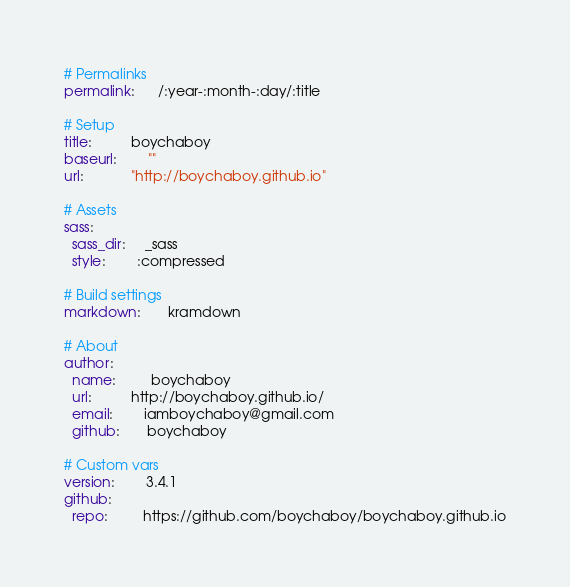Convert code to text. <code><loc_0><loc_0><loc_500><loc_500><_YAML_># Permalinks
permalink:      /:year-:month-:day/:title

# Setup
title:          boychaboy
baseurl:        ""
url:            "http://boychaboy.github.io"

# Assets
sass:
  sass_dir:     _sass
  style:        :compressed

# Build settings
markdown:       kramdown

# About
author:
  name:         boychaboy
  url:          http://boychaboy.github.io/
  email:        iamboychaboy@gmail.com  
  github:       boychaboy

# Custom vars
version:        3.4.1
github:
  repo:         https://github.com/boychaboy/boychaboy.github.io
</code> 